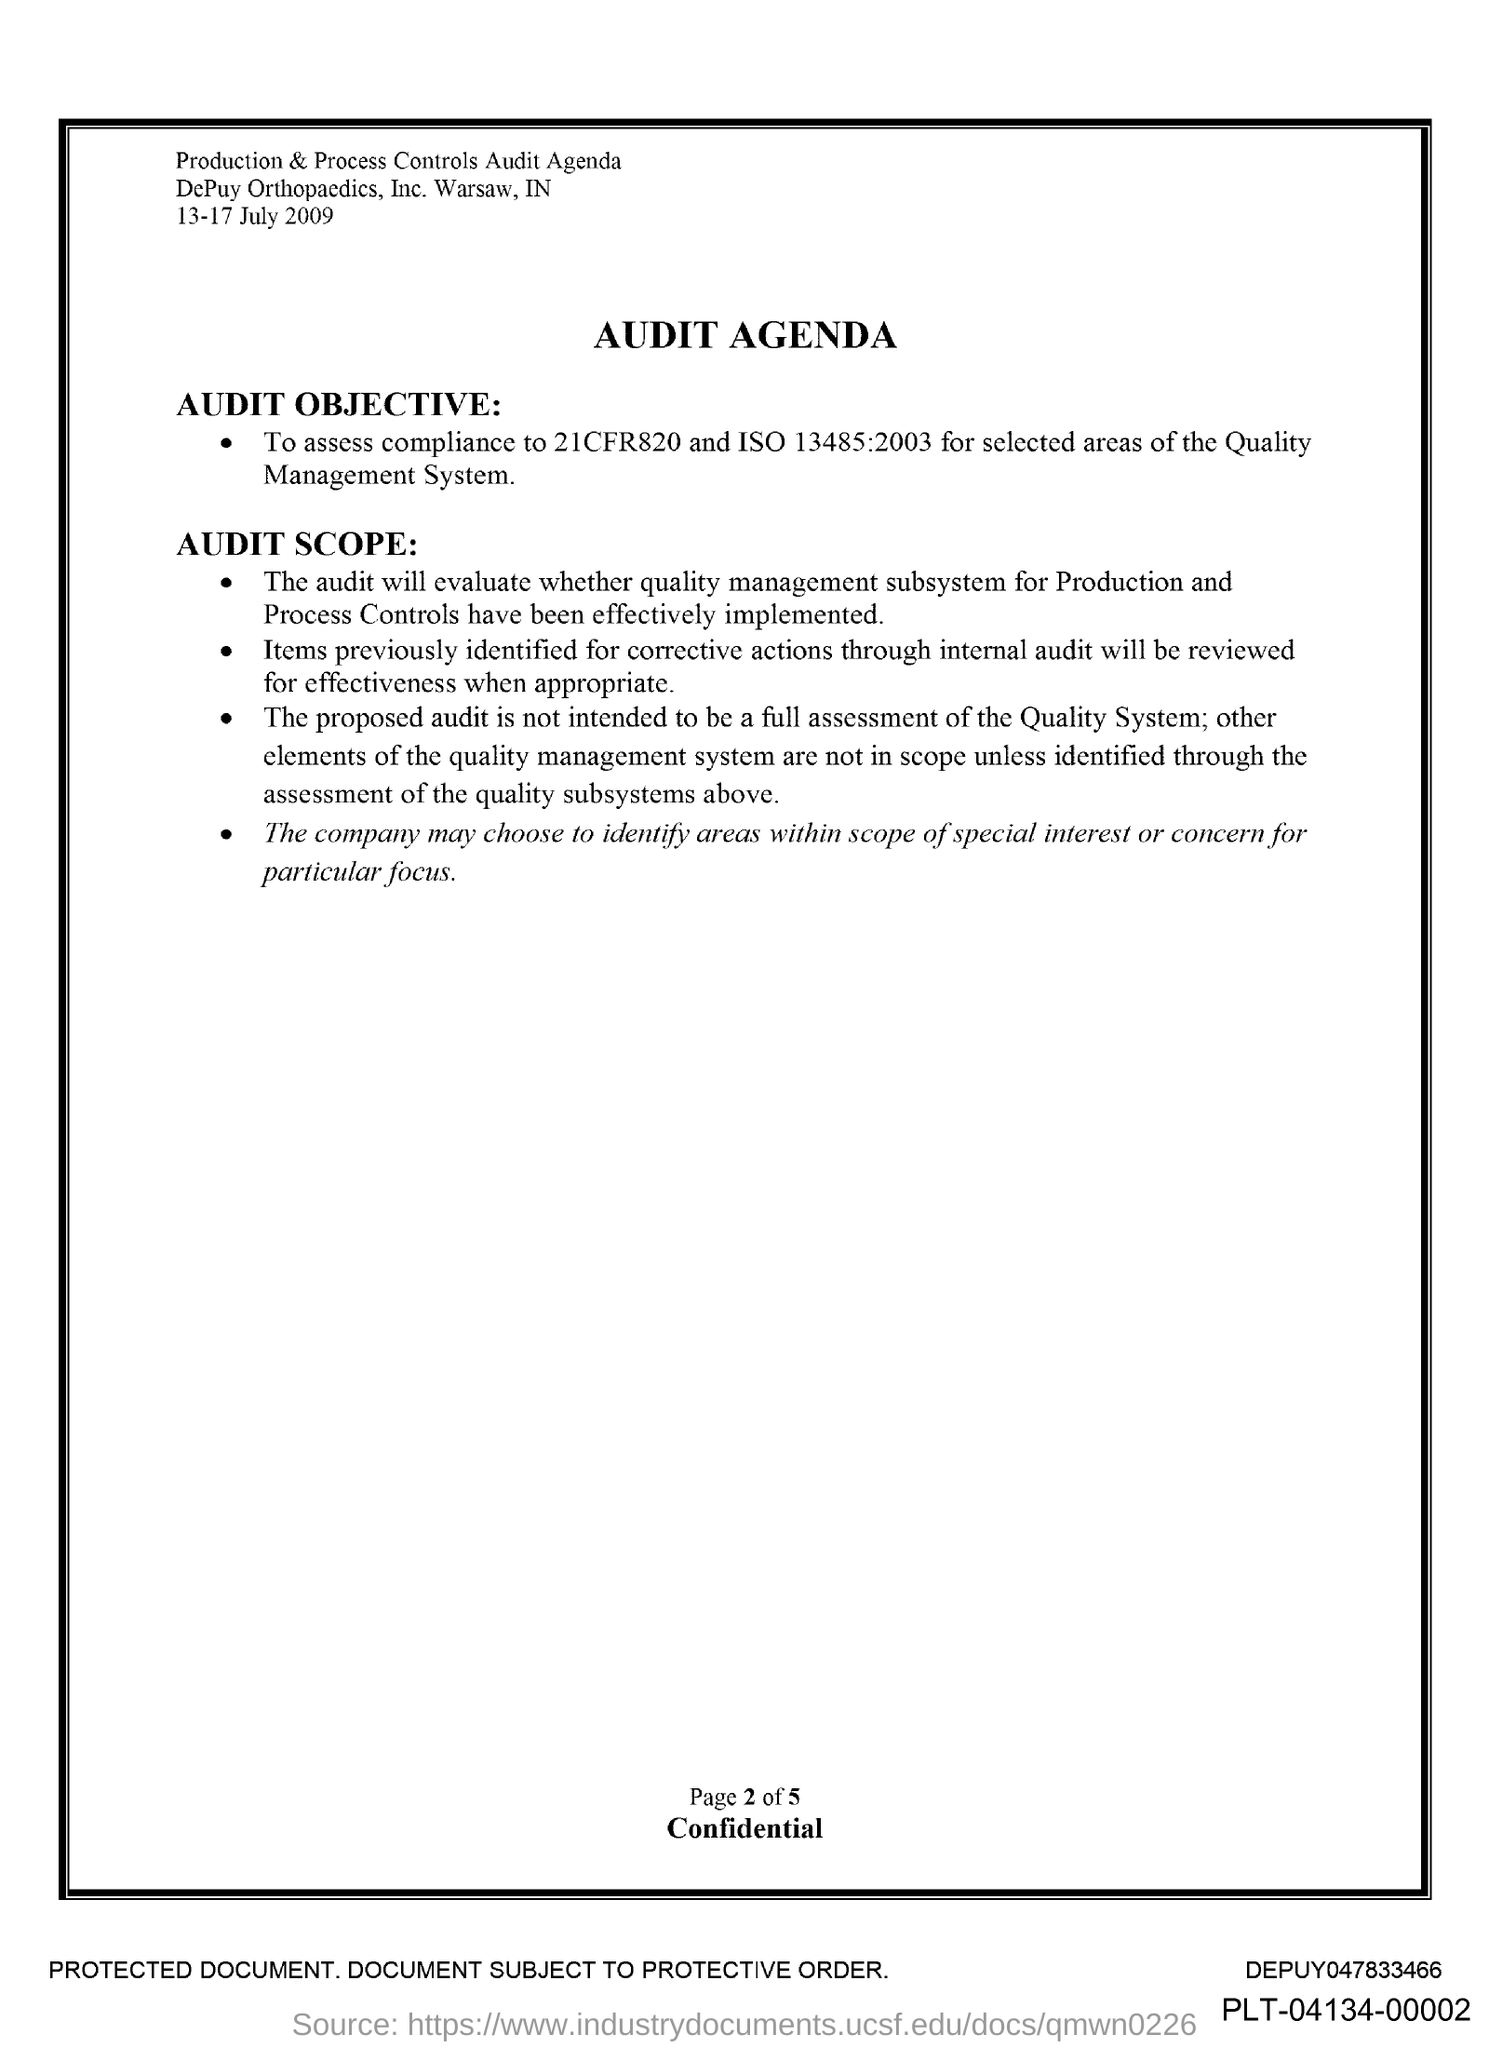Indicate a few pertinent items in this graphic. The date indicated is 13-17 July 2009. This document pertains to an audit agenda. 